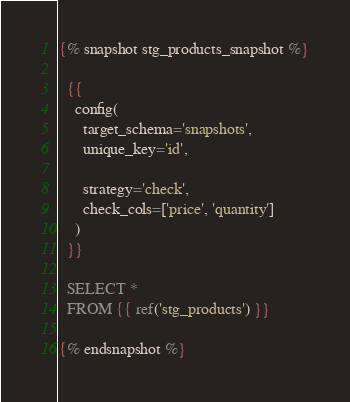<code> <loc_0><loc_0><loc_500><loc_500><_SQL_>{% snapshot stg_products_snapshot %}

  {{
    config(
      target_schema='snapshots',
      unique_key='id',

      strategy='check',
      check_cols=['price', 'quantity']
    )
  }}

  SELECT * 
  FROM {{ ref('stg_products') }}

{% endsnapshot %}</code> 